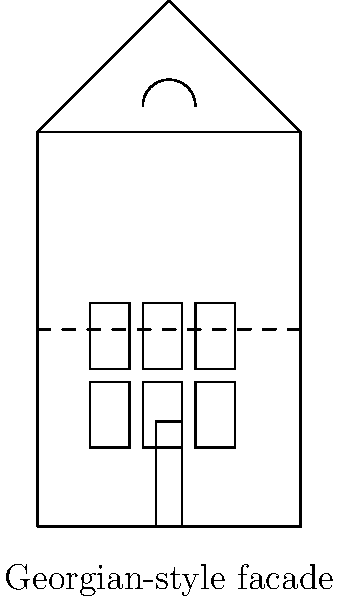Analyze the architectural features shown in the facade diagram of this historic Camberley building. Which architectural style does it most closely represent, and what specific elements support this classification? To determine the architectural style of this historic Camberley building, we need to analyze its key features:

1. Symmetry: The facade shows a symmetrical arrangement of windows and door, which is a hallmark of Georgian architecture.

2. Windows: There are six evenly spaced, rectangular windows arranged in a 3x2 grid. This regular fenestration pattern is typical of Georgian style.

3. Door: The central door placement contributes to the overall symmetry, another Georgian characteristic.

4. Roof: The building has a triangular pediment-like roof, which is common in Georgian architecture.

5. Decorative elements: 
   a) The dashed line across the facade suggests a string course, a horizontal band used in Georgian architecture to delineate floors.
   b) The semicircular element above the top central window resembles a fanlight, often used in Georgian buildings.

6. Proportions: The overall proportions of the building, with its rectangular shape and balanced facade, align with Georgian principles of design.

7. Simplicity: The facade is relatively unadorned, focusing on symmetry and proportion rather than elaborate decoration, which is consistent with Georgian style.

These features, when considered together, strongly indicate that this building represents Georgian architectural style, which was prevalent in England from about 1714 to the 1830s. This period coincides with the reigns of the first four British monarchs of the House of Hanover, after whom the style is named.

Georgian architecture was known for its emphasis on proportion, balance, and symmetry, all of which are evident in this facade diagram. The style was heavily influenced by Palladian architecture and aimed to convey a sense of elegance and refinement.
Answer: Georgian style; symmetrical facade, regular window arrangement, central door, pediment-like roof, and simple decorative elements. 